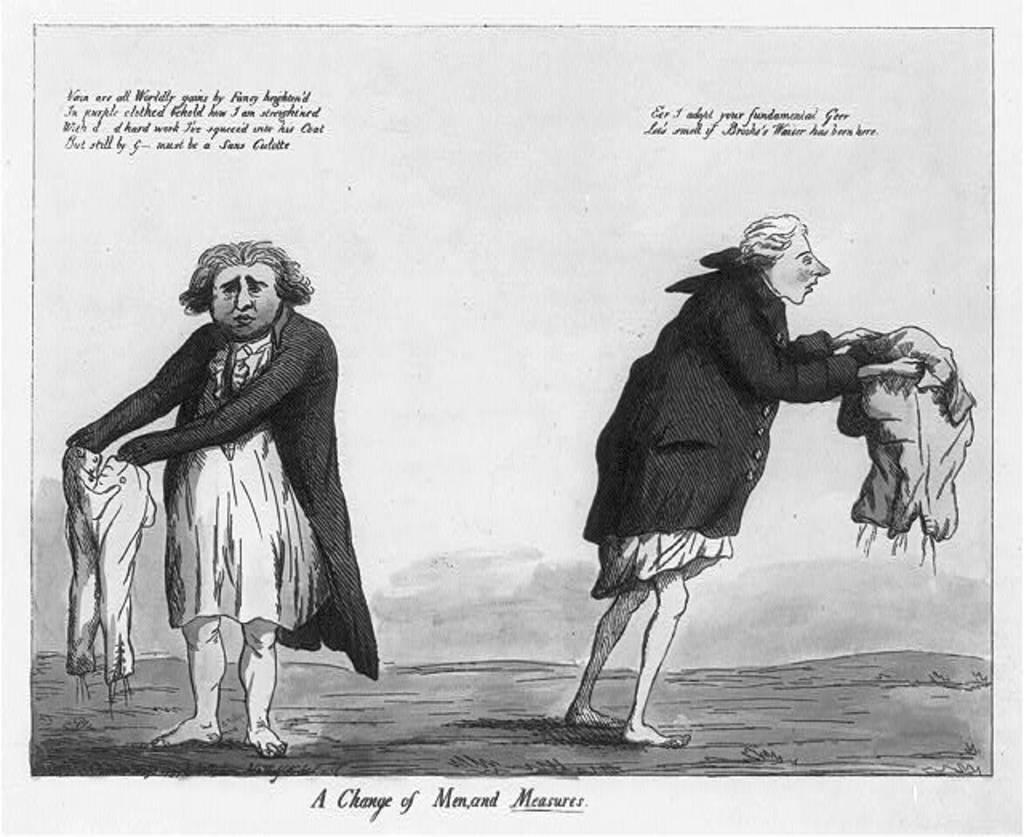In one or two sentences, can you explain what this image depicts? As we can see in the image there is a poster. In poster there are two people standing. 